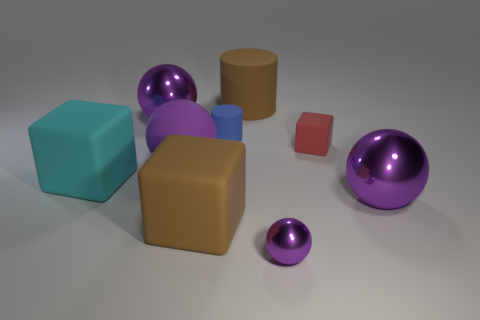Subtract all large matte blocks. How many blocks are left? 1 Subtract all brown cubes. How many cubes are left? 2 Subtract all blocks. How many objects are left? 6 Add 3 gray things. How many gray things exist? 3 Add 1 tiny blue things. How many objects exist? 10 Subtract 0 gray cylinders. How many objects are left? 9 Subtract 3 cubes. How many cubes are left? 0 Subtract all brown cylinders. Subtract all green balls. How many cylinders are left? 1 Subtract all gray spheres. How many purple cylinders are left? 0 Subtract all big yellow metal spheres. Subtract all big things. How many objects are left? 3 